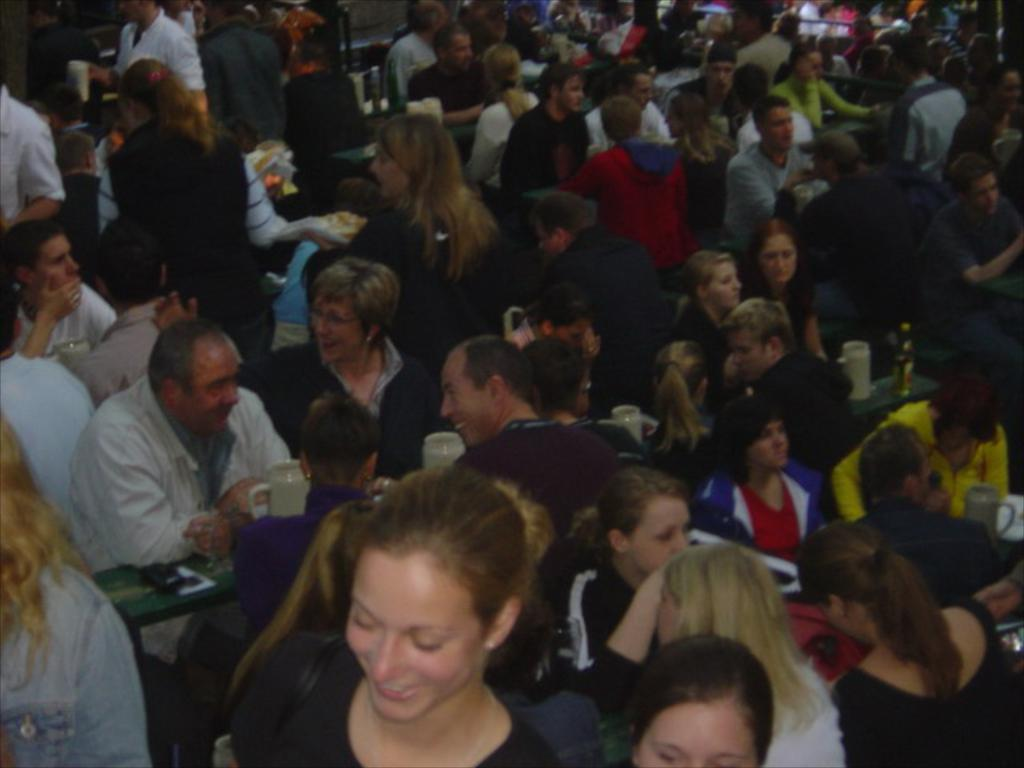What is the main subject of the image? The main subject of the image is a group of people. What are some of the people in the image doing? Some of the people are sitting, while others are busy with their own works. Are there any people standing in the image? Yes, there are people standing in the image. What type of dog can be seen playing with the people in the image? There is no dog present in the image; it only features a group of people. 